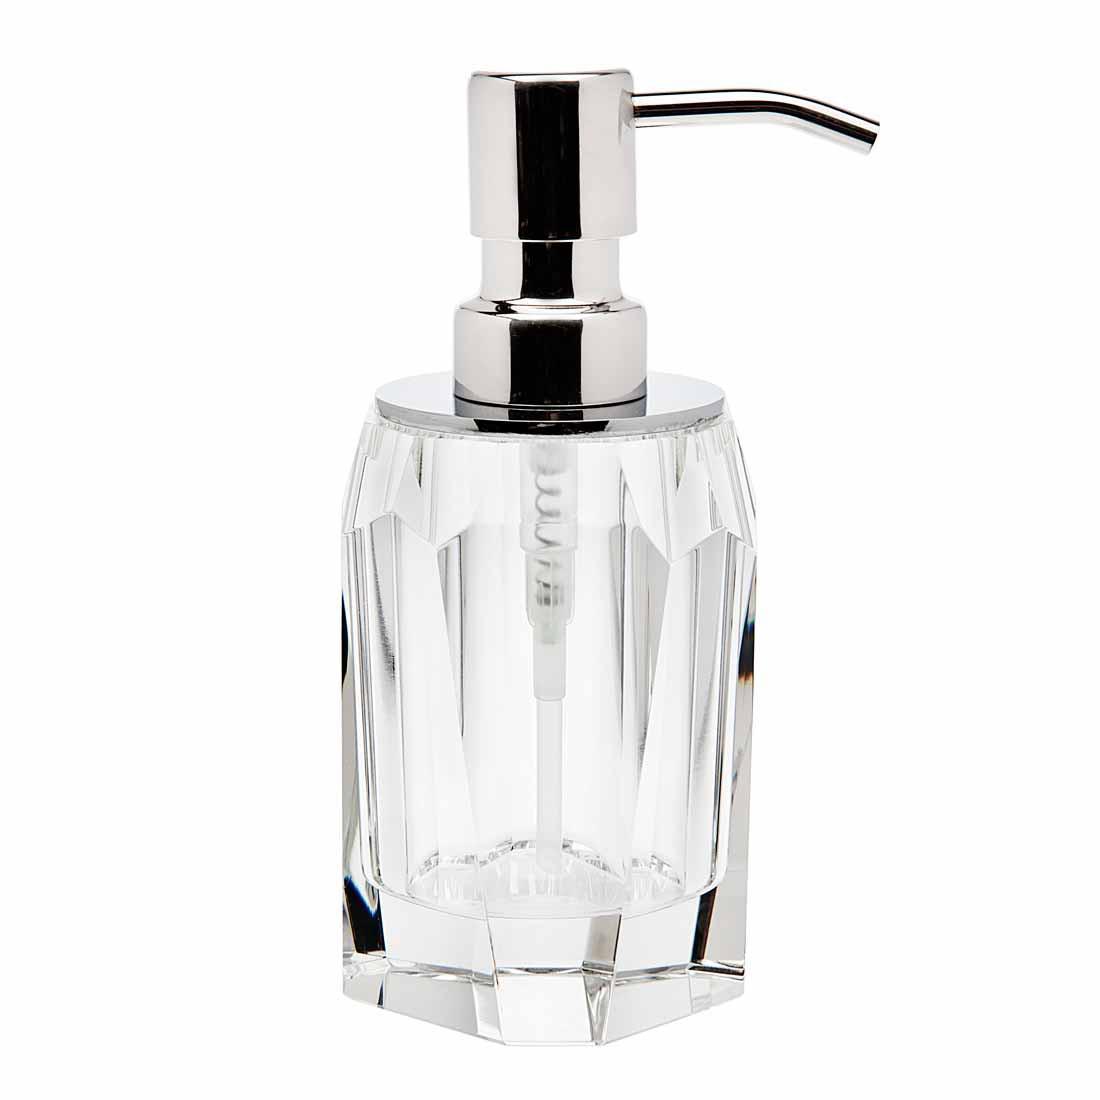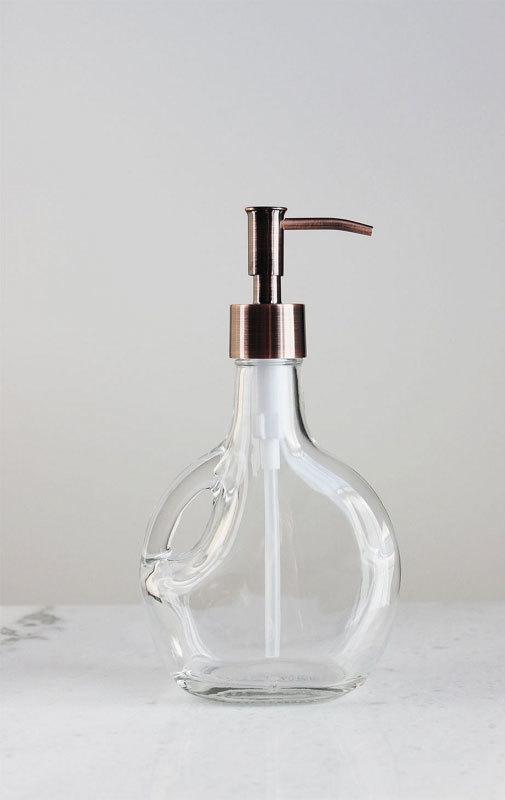The first image is the image on the left, the second image is the image on the right. For the images displayed, is the sentence "The dispenser in both pictures is pointing toward the left." factually correct? Answer yes or no. No. The first image is the image on the left, the second image is the image on the right. Analyze the images presented: Is the assertion "The right image is an empty soap dispenser facing to the right." valid? Answer yes or no. Yes. 